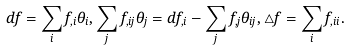<formula> <loc_0><loc_0><loc_500><loc_500>d f = \sum _ { i } f _ { , i } \theta _ { i } , \sum _ { j } f _ { , i j } \theta _ { j } = d f _ { , i } - \sum _ { j } f _ { , j } \theta _ { i j } , \triangle f = \sum _ { i } f _ { , i i } .</formula> 